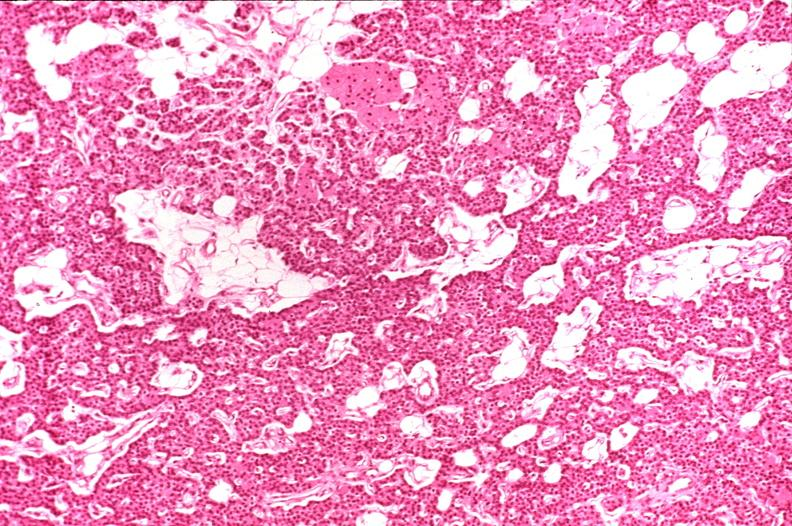does quite good liver show parathyroid, normal?
Answer the question using a single word or phrase. No 